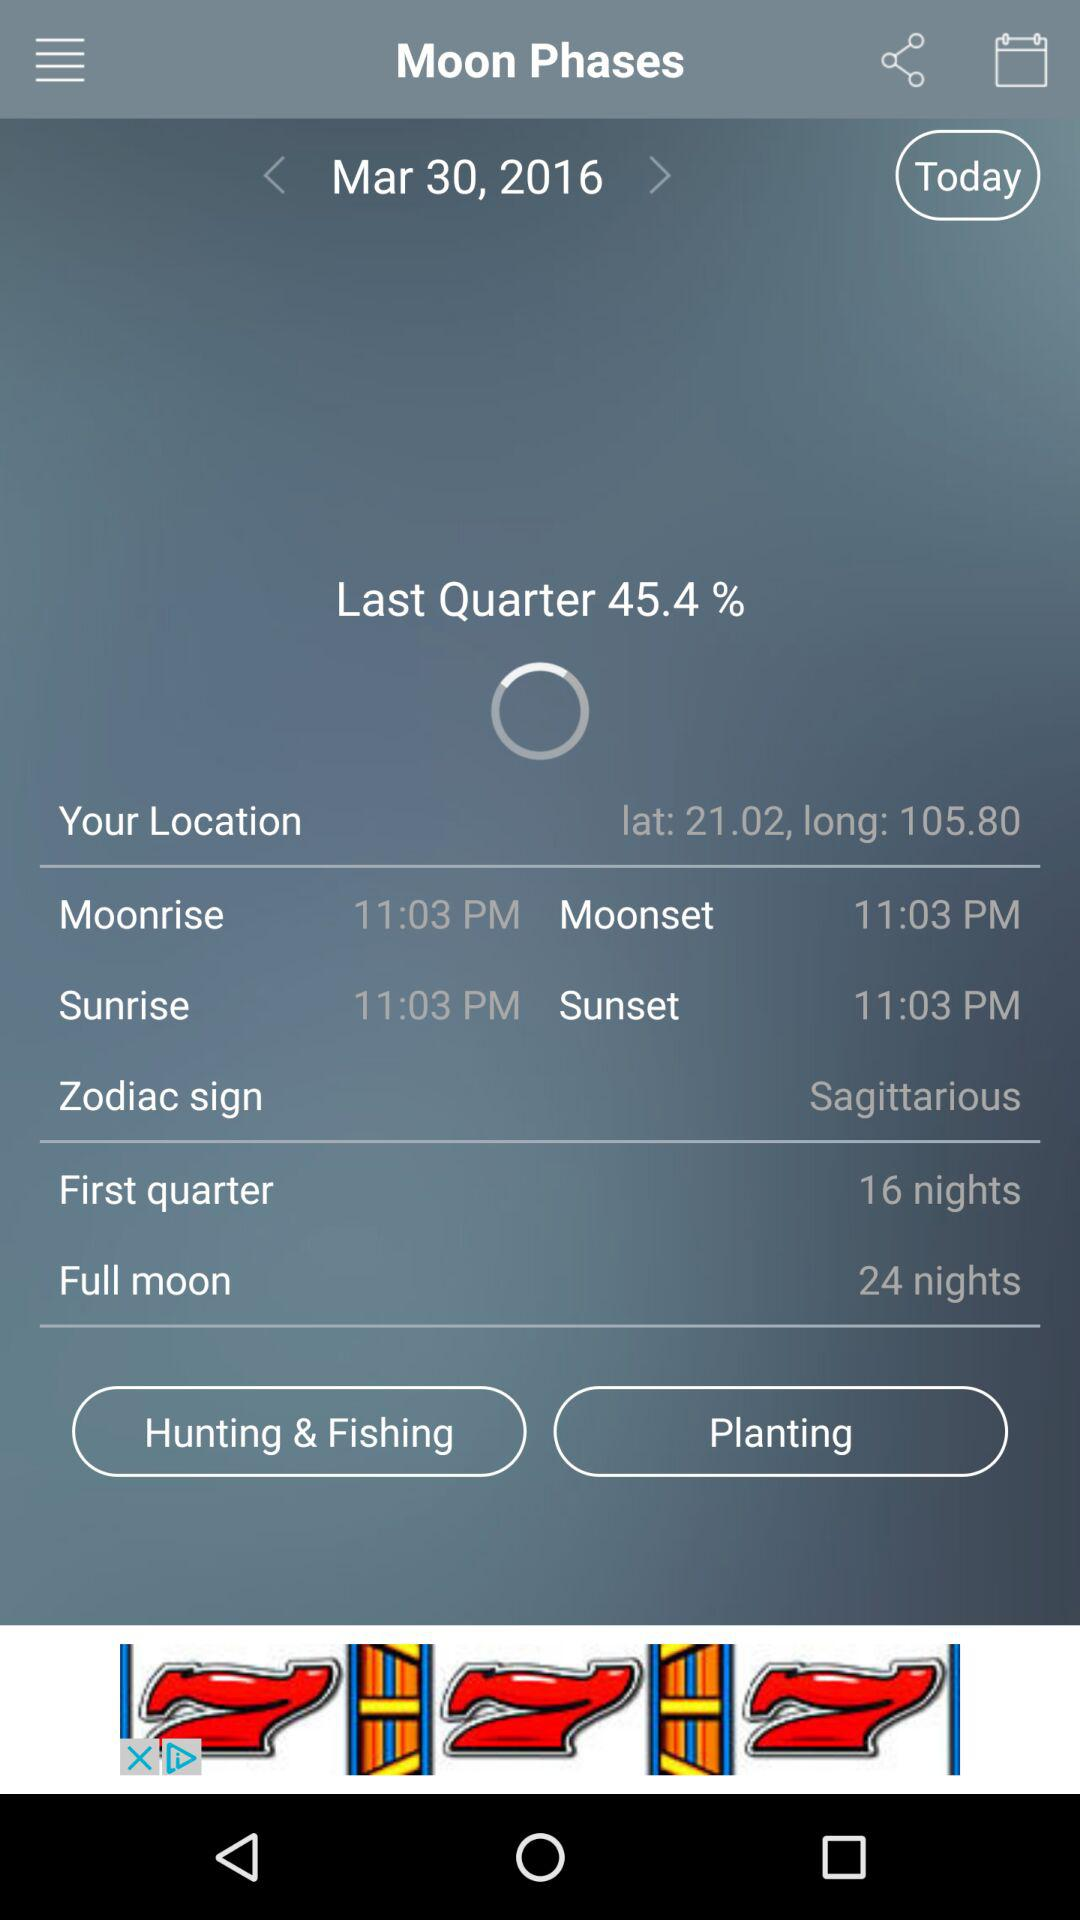How many nights are left until the full moon? There are 24 nights left until the full moon. 